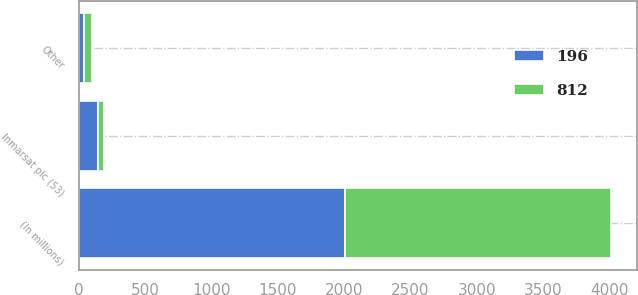Convert chart to OTSL. <chart><loc_0><loc_0><loc_500><loc_500><stacked_bar_chart><ecel><fcel>(In millions)<fcel>Other<fcel>Inmarsat plc (53)<nl><fcel>196<fcel>2005<fcel>41<fcel>146<nl><fcel>812<fcel>2004<fcel>57<fcel>46<nl></chart> 